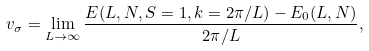Convert formula to latex. <formula><loc_0><loc_0><loc_500><loc_500>v _ { \sigma } = \lim _ { L \rightarrow \infty } \frac { E ( L , N , S = 1 , k = 2 \pi / L ) - E _ { 0 } ( L , N ) } { 2 \pi / L } ,</formula> 